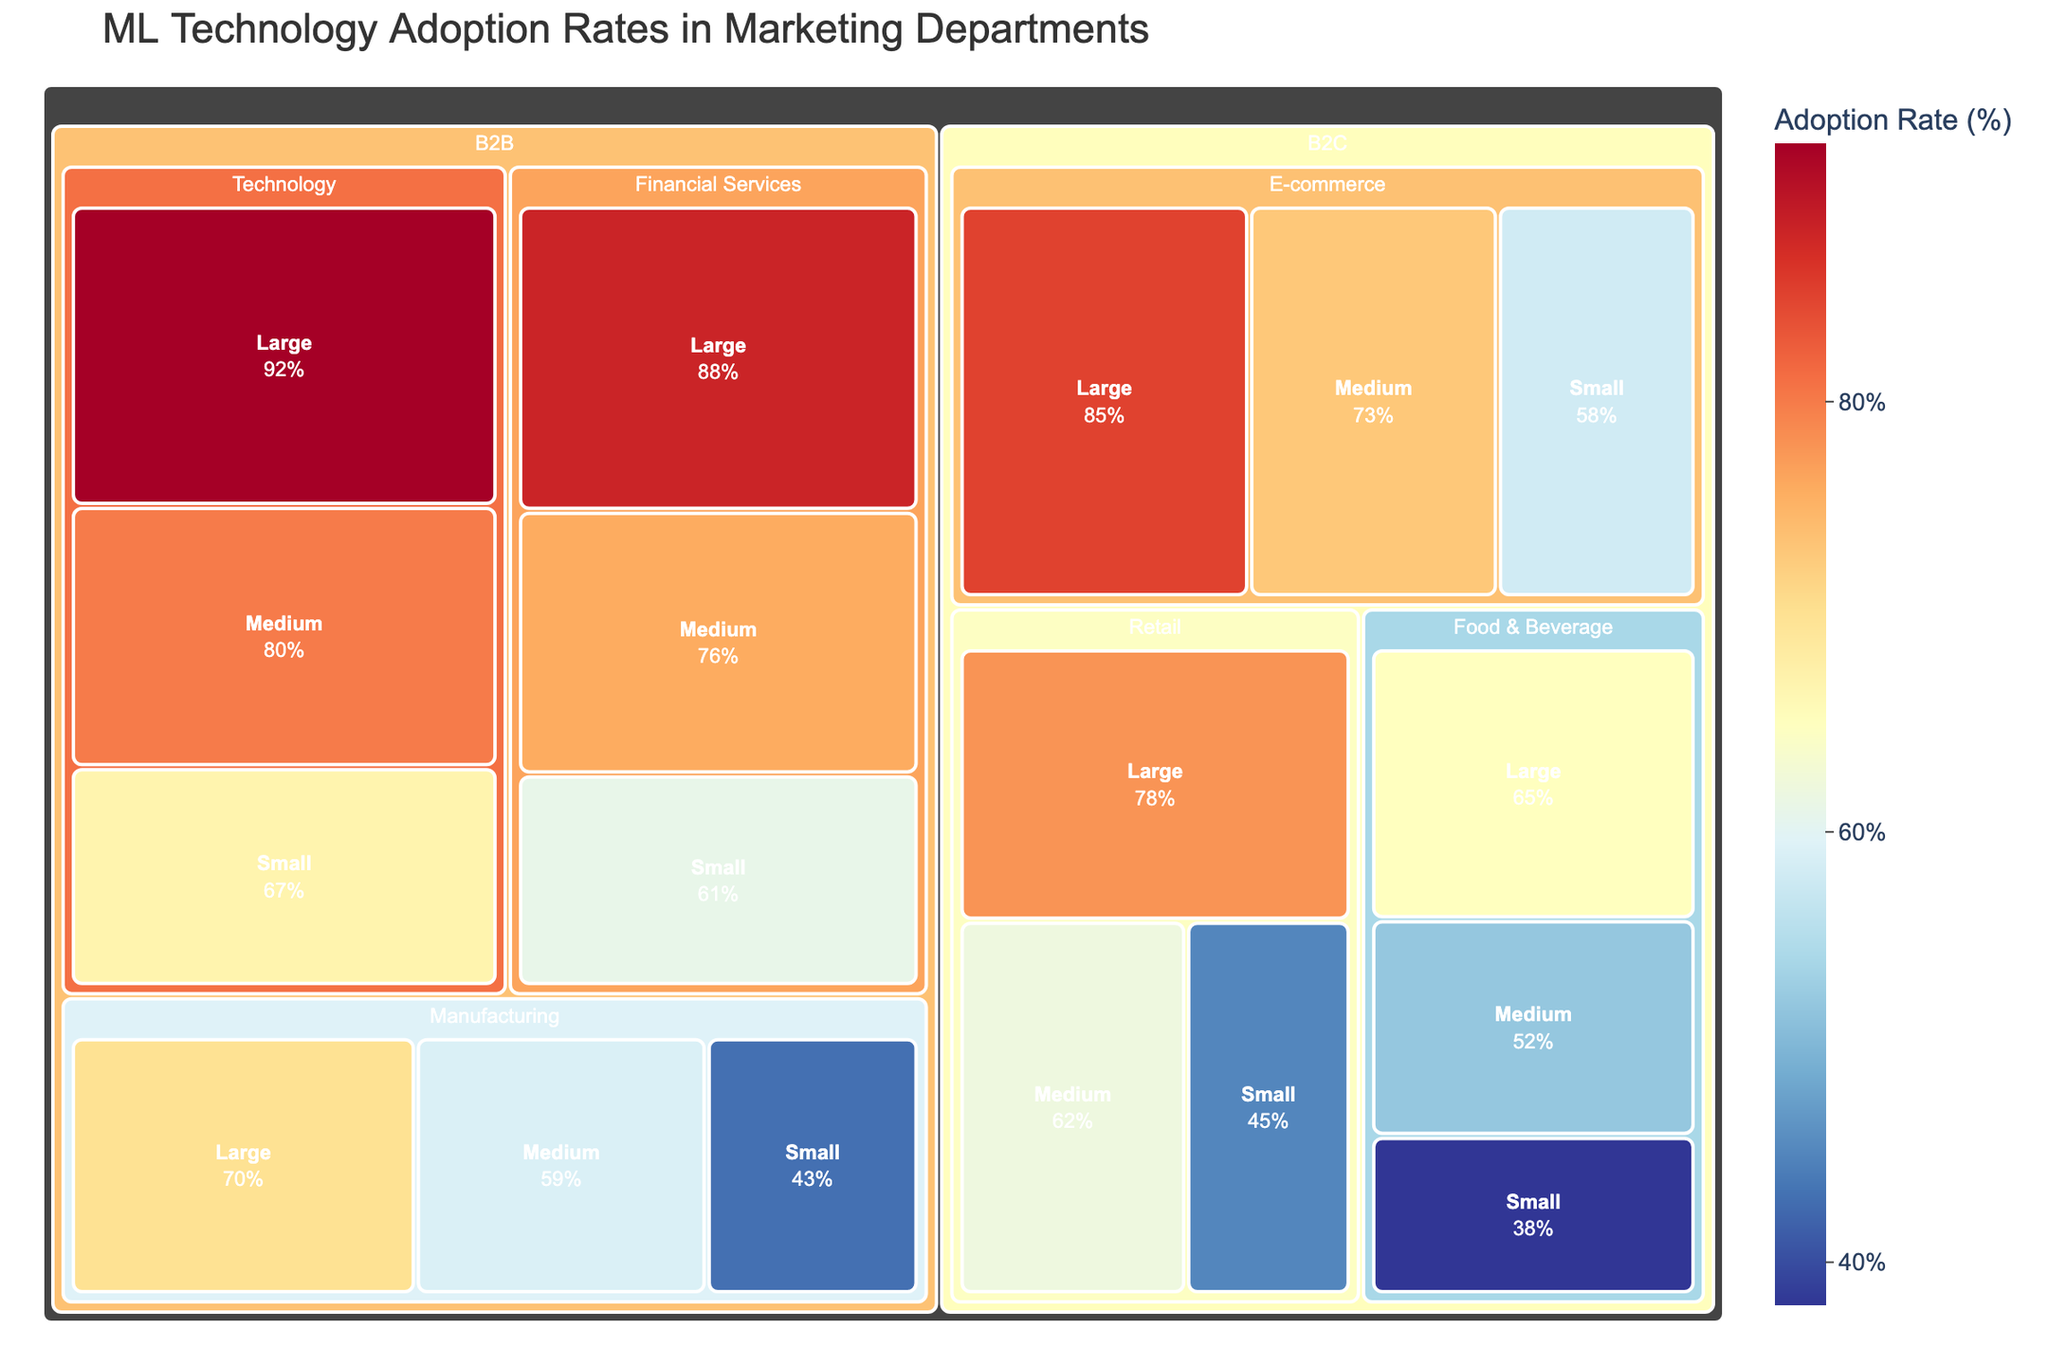What's the title of the treemap? The title of the treemap is located at the top part of the plot. It provides an overview of what the treemap represents.
Answer: ML Technology Adoption Rates in Marketing Departments What is the adoption rate of machine learning technologies in large retail companies? Find the "B2C" category, locate "Retail" sector, and then look for "Large" company size to find the adoption rate.
Answer: 78% Which sector has the highest machine learning adoption rate in B2C for small-sized companies? Traverse the "B2C" category, compare the "Small" sizes across different sectors. E-commerce has the highest rate when compared to Retail and Food & Beverage.
Answer: E-commerce What's the average adoption rate for medium-sized companies in the Technology sector? Identify the adoption rates for "Medium" company size under the "B2B" category and "Technology" sector. Only one value is present: 80%. Thus, the average is simply 80.
Answer: 80% Compare the adoption rates between large and small food & beverage companies in B2C. Which one is higher? Under the "B2C" category and "Food & Beverage" sector, compare the values for "Large" (65) and "Small" (38) company sizes.
Answer: Large Which category and sector has a 70% adoption rate for large-sized companies? Search through both "B2C" and "B2B" categories to find a sector with a large size adoption rate of 70%. It falls under the "B2B" category and "Manufacturing" sector.
Answer: B2B, Manufacturing What is the range of adoption rates in the B2B category for medium-sized companies? Locate the adoption rates for "Medium" sized companies under the "B2B" category. The rates are: Technology (80), Manufacturing (59), Financial Services (76). Subtract the smallest value from the largest: 80 - 59.
Answer: 21% Identify the sector in the B2B category with the lowest adoption rate for small companies. Navigate to the "B2B" category, compare the adoption rates for "Small" company sizes across sectors: Technology (67), Manufacturing (43), Financial Services (61).
Answer: Manufacturing Which category, sector, and company size combination has the highest adoption rate among all the data points? Identify the highest adoption rate across all categories. B2B, Technology for Large-sized companies has the highest rate of 92%.
Answer: B2B, Technology, Large What's the combined adoption rate for medium-sized companies across all sectors in the B2C category? Find the "B2C" category and sum the adoption rates for "Medium" company sizes: Retail (62), E-commerce (73), Food & Beverage (52). The sum is 62 + 73 + 52 = 187.
Answer: 187 